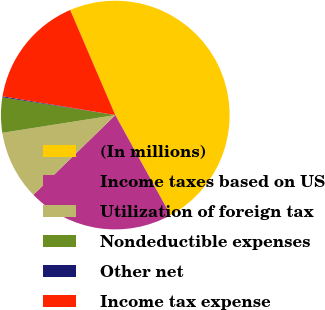<chart> <loc_0><loc_0><loc_500><loc_500><pie_chart><fcel>(In millions)<fcel>Income taxes based on US<fcel>Utilization of foreign tax<fcel>Nondeductible expenses<fcel>Other net<fcel>Income tax expense<nl><fcel>48.42%<fcel>20.74%<fcel>9.8%<fcel>4.97%<fcel>0.14%<fcel>15.92%<nl></chart> 